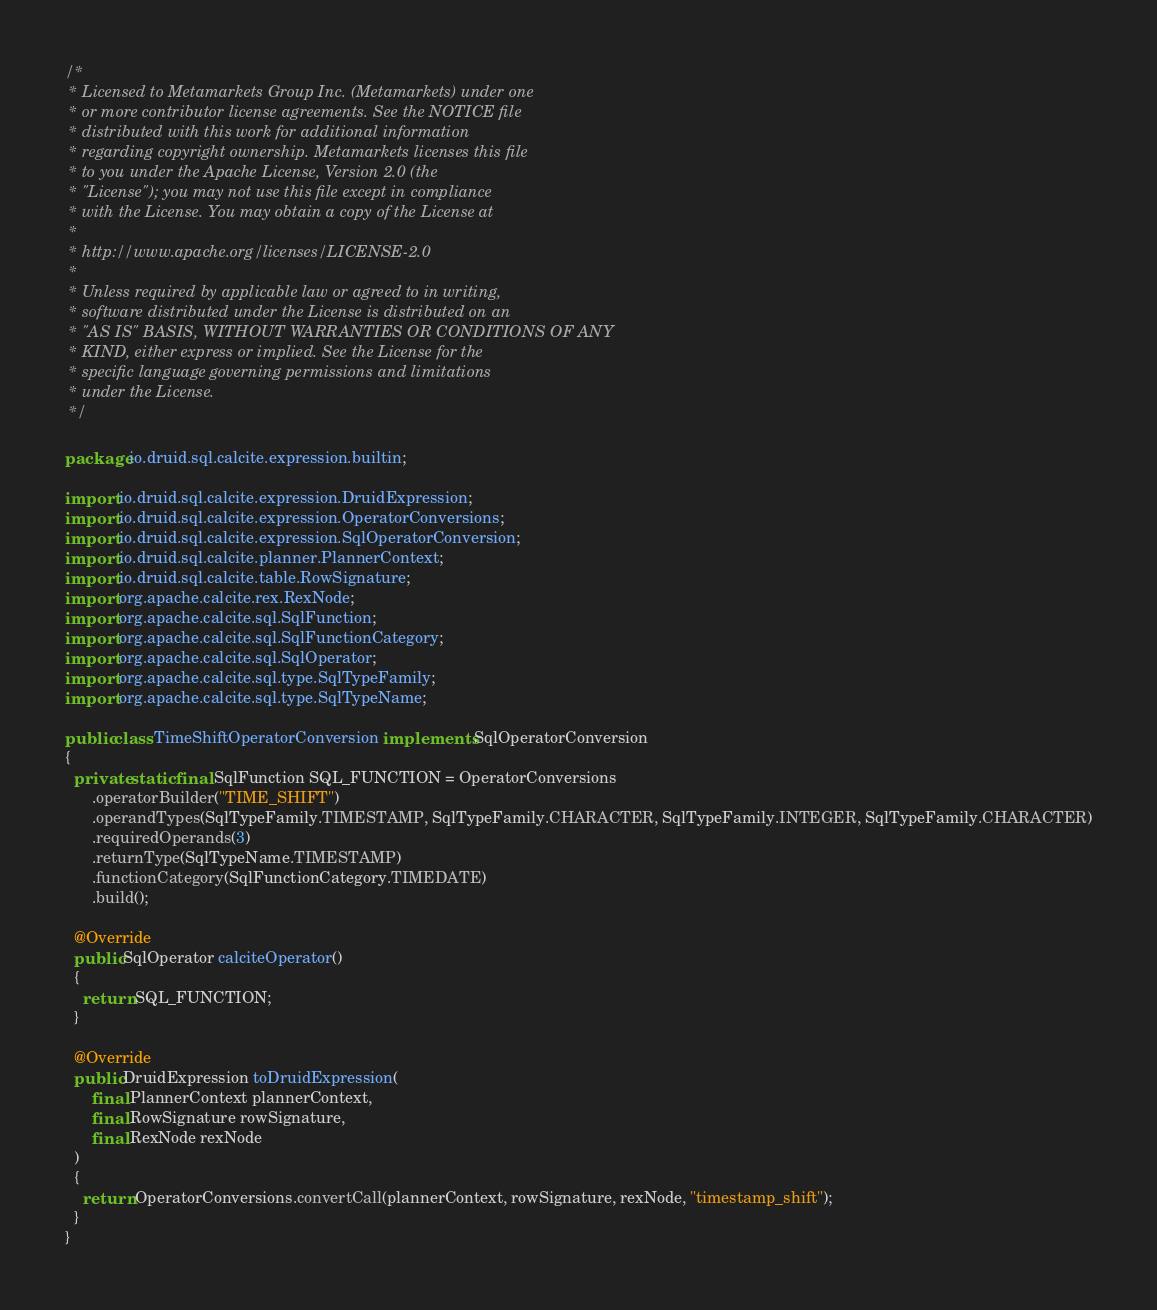<code> <loc_0><loc_0><loc_500><loc_500><_Java_>/*
 * Licensed to Metamarkets Group Inc. (Metamarkets) under one
 * or more contributor license agreements. See the NOTICE file
 * distributed with this work for additional information
 * regarding copyright ownership. Metamarkets licenses this file
 * to you under the Apache License, Version 2.0 (the
 * "License"); you may not use this file except in compliance
 * with the License. You may obtain a copy of the License at
 *
 * http://www.apache.org/licenses/LICENSE-2.0
 *
 * Unless required by applicable law or agreed to in writing,
 * software distributed under the License is distributed on an
 * "AS IS" BASIS, WITHOUT WARRANTIES OR CONDITIONS OF ANY
 * KIND, either express or implied. See the License for the
 * specific language governing permissions and limitations
 * under the License.
 */

package io.druid.sql.calcite.expression.builtin;

import io.druid.sql.calcite.expression.DruidExpression;
import io.druid.sql.calcite.expression.OperatorConversions;
import io.druid.sql.calcite.expression.SqlOperatorConversion;
import io.druid.sql.calcite.planner.PlannerContext;
import io.druid.sql.calcite.table.RowSignature;
import org.apache.calcite.rex.RexNode;
import org.apache.calcite.sql.SqlFunction;
import org.apache.calcite.sql.SqlFunctionCategory;
import org.apache.calcite.sql.SqlOperator;
import org.apache.calcite.sql.type.SqlTypeFamily;
import org.apache.calcite.sql.type.SqlTypeName;

public class TimeShiftOperatorConversion implements SqlOperatorConversion
{
  private static final SqlFunction SQL_FUNCTION = OperatorConversions
      .operatorBuilder("TIME_SHIFT")
      .operandTypes(SqlTypeFamily.TIMESTAMP, SqlTypeFamily.CHARACTER, SqlTypeFamily.INTEGER, SqlTypeFamily.CHARACTER)
      .requiredOperands(3)
      .returnType(SqlTypeName.TIMESTAMP)
      .functionCategory(SqlFunctionCategory.TIMEDATE)
      .build();

  @Override
  public SqlOperator calciteOperator()
  {
    return SQL_FUNCTION;
  }

  @Override
  public DruidExpression toDruidExpression(
      final PlannerContext plannerContext,
      final RowSignature rowSignature,
      final RexNode rexNode
  )
  {
    return OperatorConversions.convertCall(plannerContext, rowSignature, rexNode, "timestamp_shift");
  }
}
</code> 